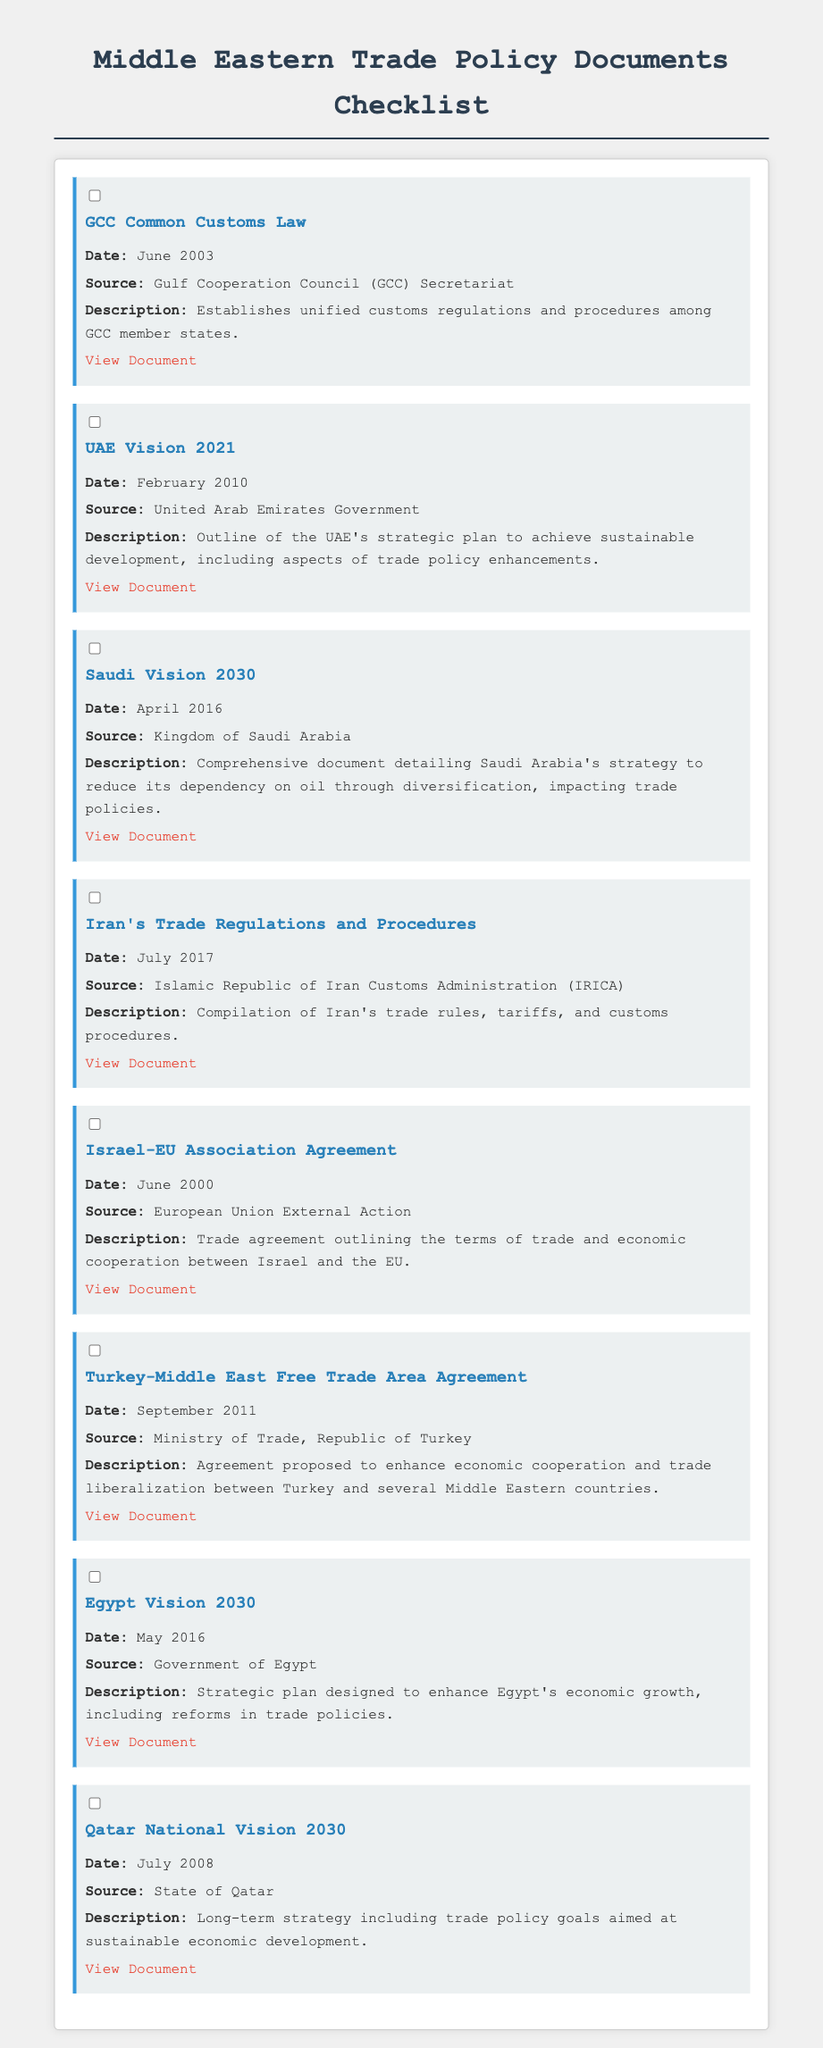What is the date of the GCC Common Customs Law? The document specifies that the GCC Common Customs Law was established in June 2003.
Answer: June 2003 Who is the source of the UAE Vision 2021? The source of UAE Vision 2021 is the United Arab Emirates Government as mentioned in the document.
Answer: United Arab Emirates Government What is the main goal of Saudi Vision 2030? The document notes that the main goal of Saudi Vision 2030 is to reduce dependency on oil through diversification.
Answer: Reduce dependency on oil Which document was released in July 2017? The document lists Iran's Trade Regulations and Procedures as the document released in July 2017.
Answer: Iran's Trade Regulations and Procedures What is the purpose of the Egypt Vision 2030? The document describes Egypt Vision 2030 as a strategic plan designed to enhance Egypt's economic growth, including reforms in trade policies.
Answer: Enhance Egypt's economic growth Which agreement outlines terms of trade between Israel and the EU? The document mentions the Israel-EU Association Agreement as the agreement outlining the terms of trade between Israel and the EU.
Answer: Israel-EU Association Agreement What is the date of Qatar National Vision 2030? The document states that Qatar National Vision 2030 was established in July 2008.
Answer: July 2008 What type of document is this checklist primarily about? The checklist focuses on documents related to trade policies in the Middle East.
Answer: Trade policies 